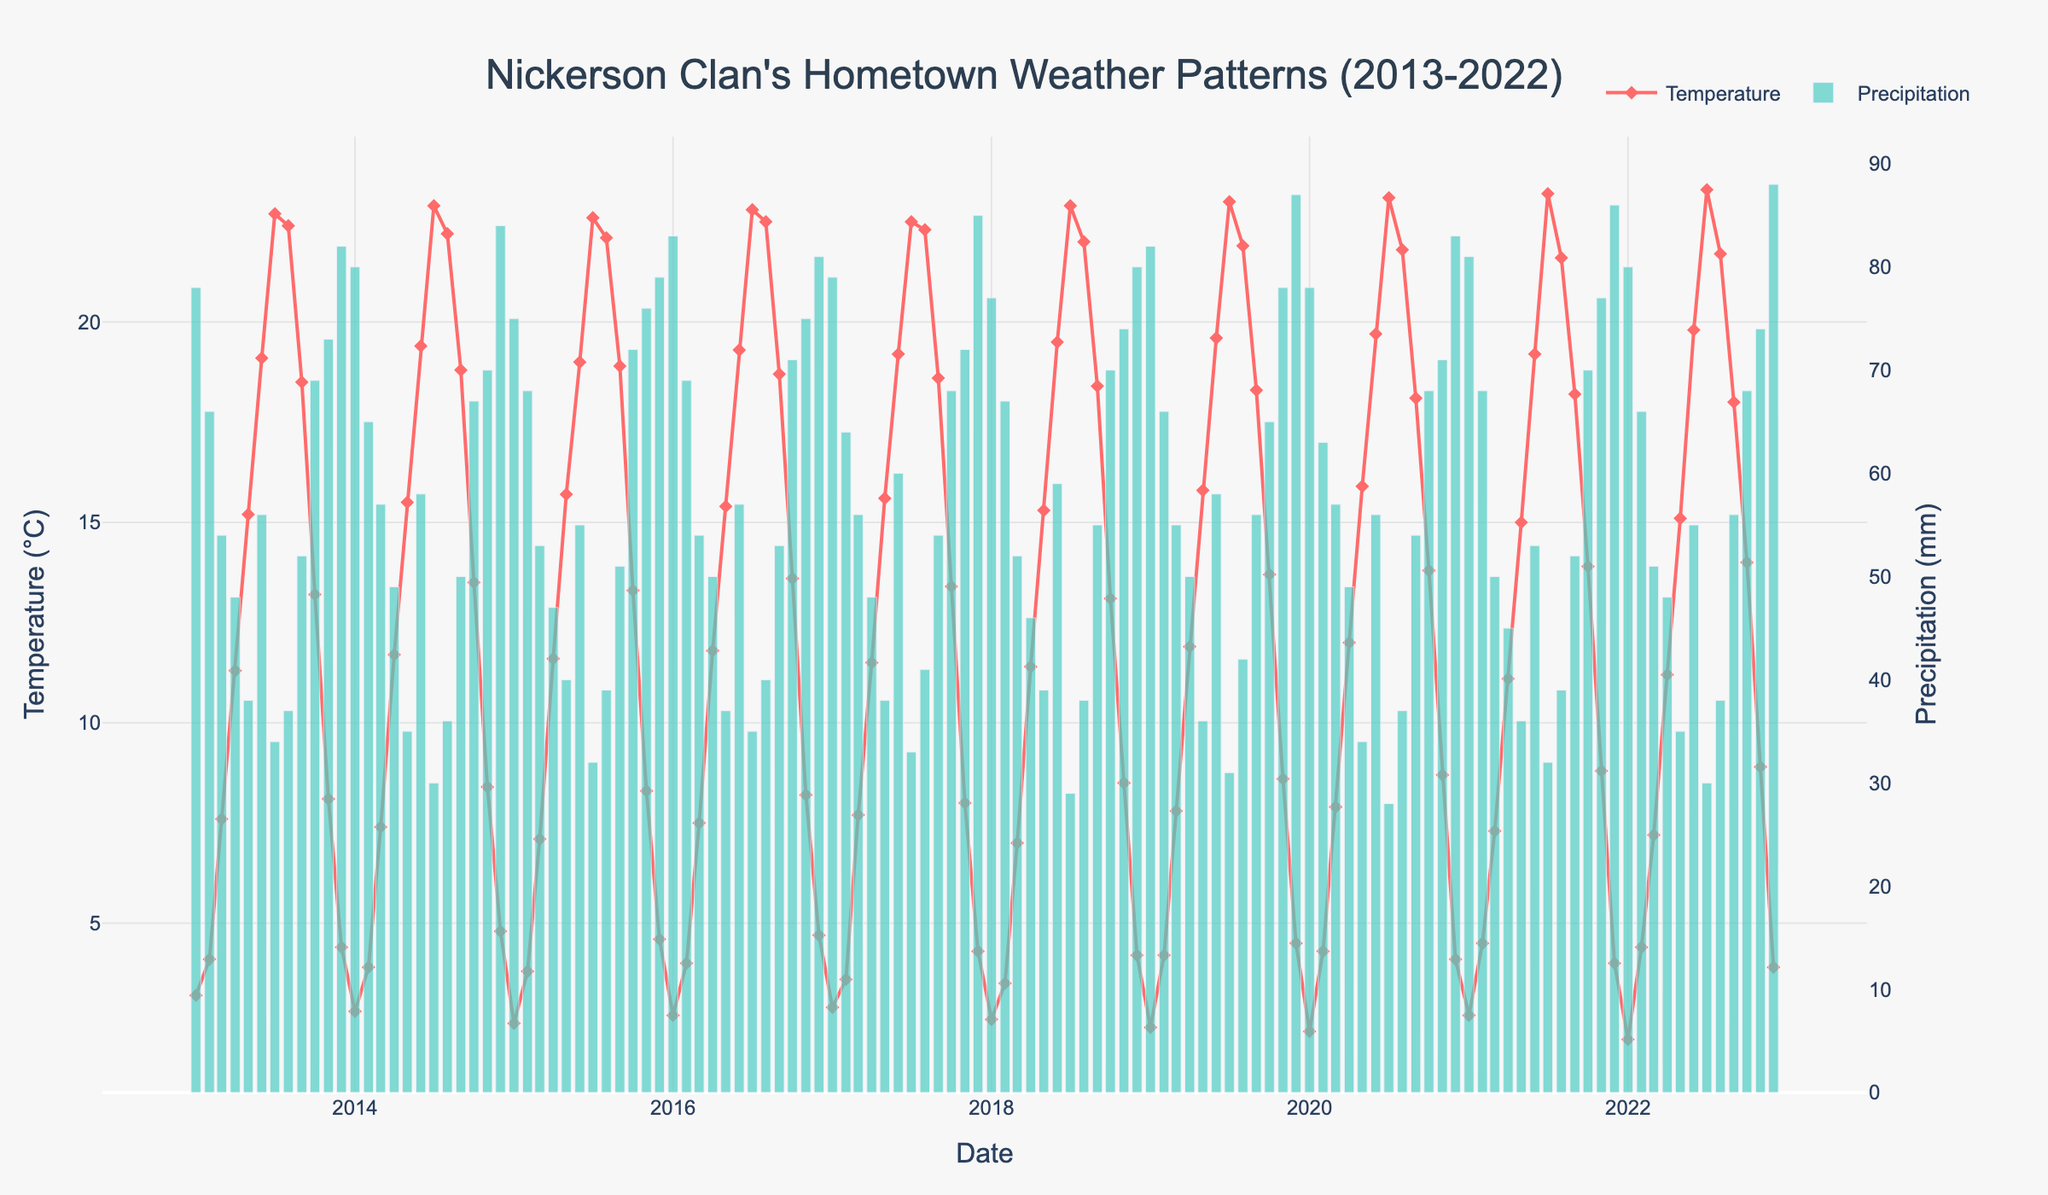What is the title of the plot? The title of the plot can be found at the top center of the figure in larger font size.
Answer: Nickerson Clan's Hometown Weather Patterns (2013-2022) Which year had the highest monthly average temperature in July? Locate the temperature line within July months and recognize the highest data point visually.
Answer: 2021 What are the two y-axes representing in the plot? The left y-axis is for temperature and the right y-axis is for precipitation. These are typically labeled and aligned with their respective data series.
Answer: Temperature and Precipitation How does the precipitation in December 2019 compare to the previous Decembers? Locate the bars for each December from 2013 to 2022 and compare their heights visually.
Answer: Higher What month and year recorded the lowest average temperature? Locate the lowest point on the temperature line across all years and check the corresponding month and year on the x-axis.
Answer: January 2022 Which month generally has the highest average temperature? Identify the peaks of the temperature line throughout the dataset and discern the most consistent highest values.
Answer: July What is the average precipitation level in June over the 10 years? Extract the precipitation bars for each June, sum these values, and divide by the number of years to find the average.
Answer: (56+58+55+57+60+59+58+56+53+55)/10 = 56.7 mm Between May 2016 and May 2017, did the precipitation level increase, decrease, or stay the same? Compare the heights of the bars for May 2016 and May 2017 to determine the change in precipitation.
Answer: Increased Has there been any year where both temperature and precipitation reached their maximum in the same month? Identify the peaks of the temperature line and the precipitation bars, then see if any month aligns for both within a single year.
Answer: No In which year did November see the highest precipitation level? Scan the bars for November across all years and identify the year with the tallest bar.
Answer: 2019 